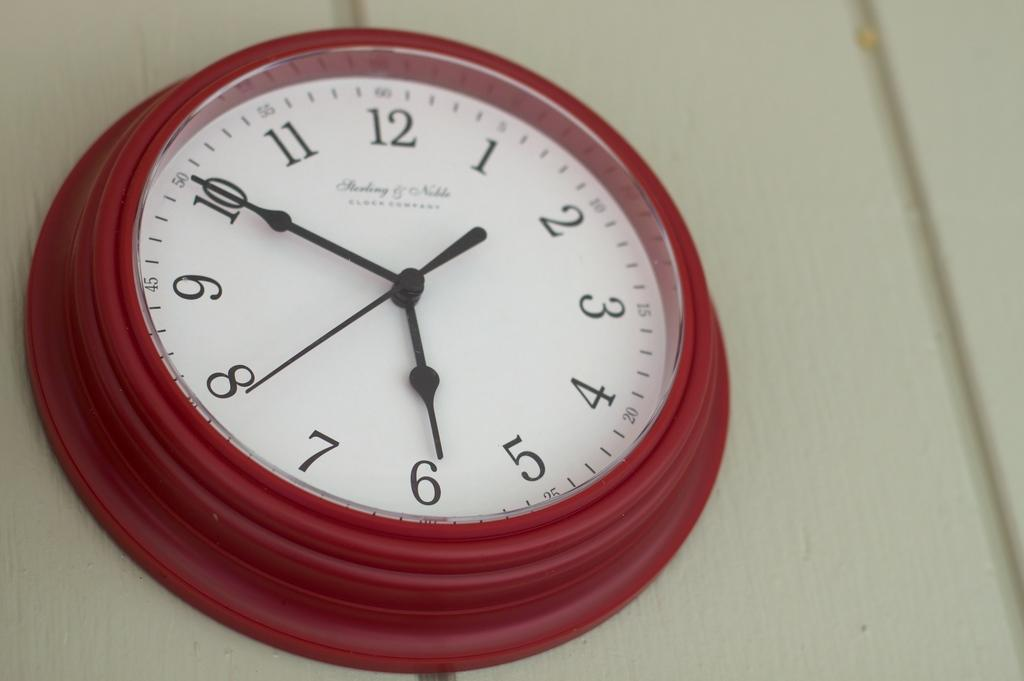<image>
Provide a brief description of the given image. A red clock on a white wall shows that the time is 5:50. 